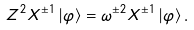Convert formula to latex. <formula><loc_0><loc_0><loc_500><loc_500>Z ^ { 2 } X ^ { \pm 1 } \left | \varphi \right \rangle = \omega ^ { \pm 2 } X ^ { \pm 1 } \left | \varphi \right \rangle .</formula> 